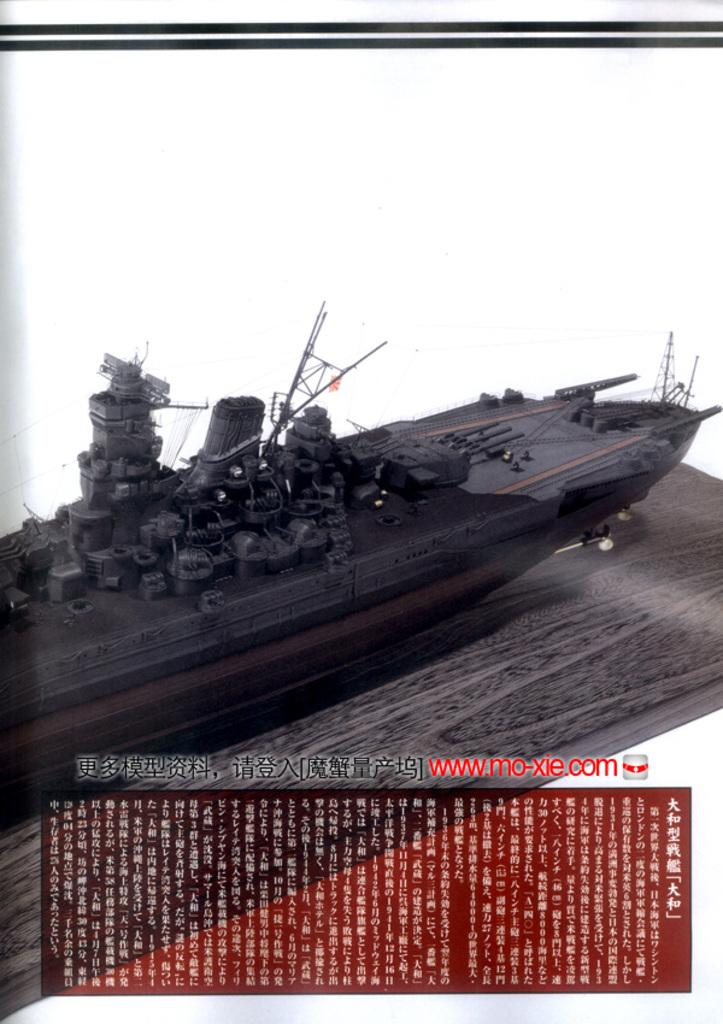What is the main subject of the image? The main subject of the image is a picture of a warship. Is there any text present in the image? Yes, there is text at the bottom of the image. What type of feather can be seen on the warship in the image? There is no feather present on the warship in the image. How does the beam support the warship in the image? There is no beam present in the image, as it is a picture of a warship and not a physical structure. 